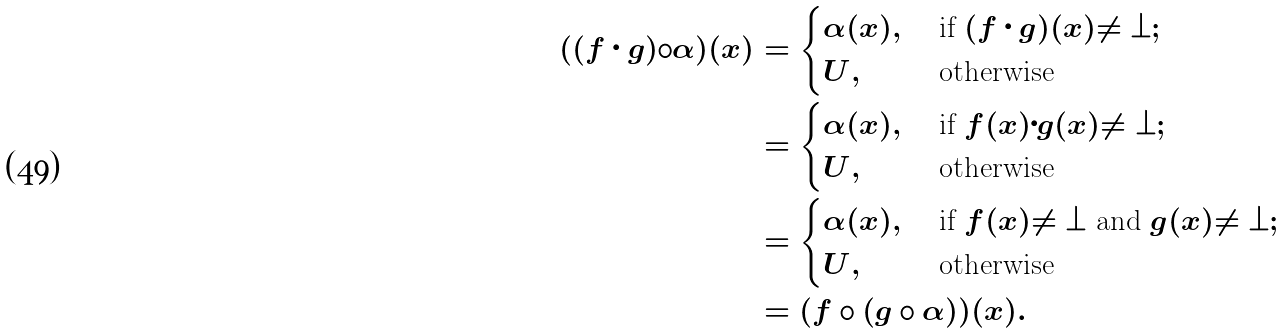<formula> <loc_0><loc_0><loc_500><loc_500>( ( f \cdot g ) \circ \alpha ) ( x ) & = \begin{cases} \alpha ( x ) , & \text { if } ( f \cdot g ) ( x ) \neq \bot ; \\ U , & \text { otherwise} \\ \end{cases} \\ & = \begin{cases} \alpha ( x ) , & \text { if } f ( x ) \cdot g ( x ) \neq \bot ; \\ U , & \text { otherwise} \\ \end{cases} \\ & = \begin{cases} \alpha ( x ) , & \text { if } f ( x ) \neq \bot \text { and } g ( x ) \neq \bot ; \\ U , & \text { otherwise} \\ \end{cases} \\ & = ( f \circ ( g \circ \alpha ) ) ( x ) .</formula> 